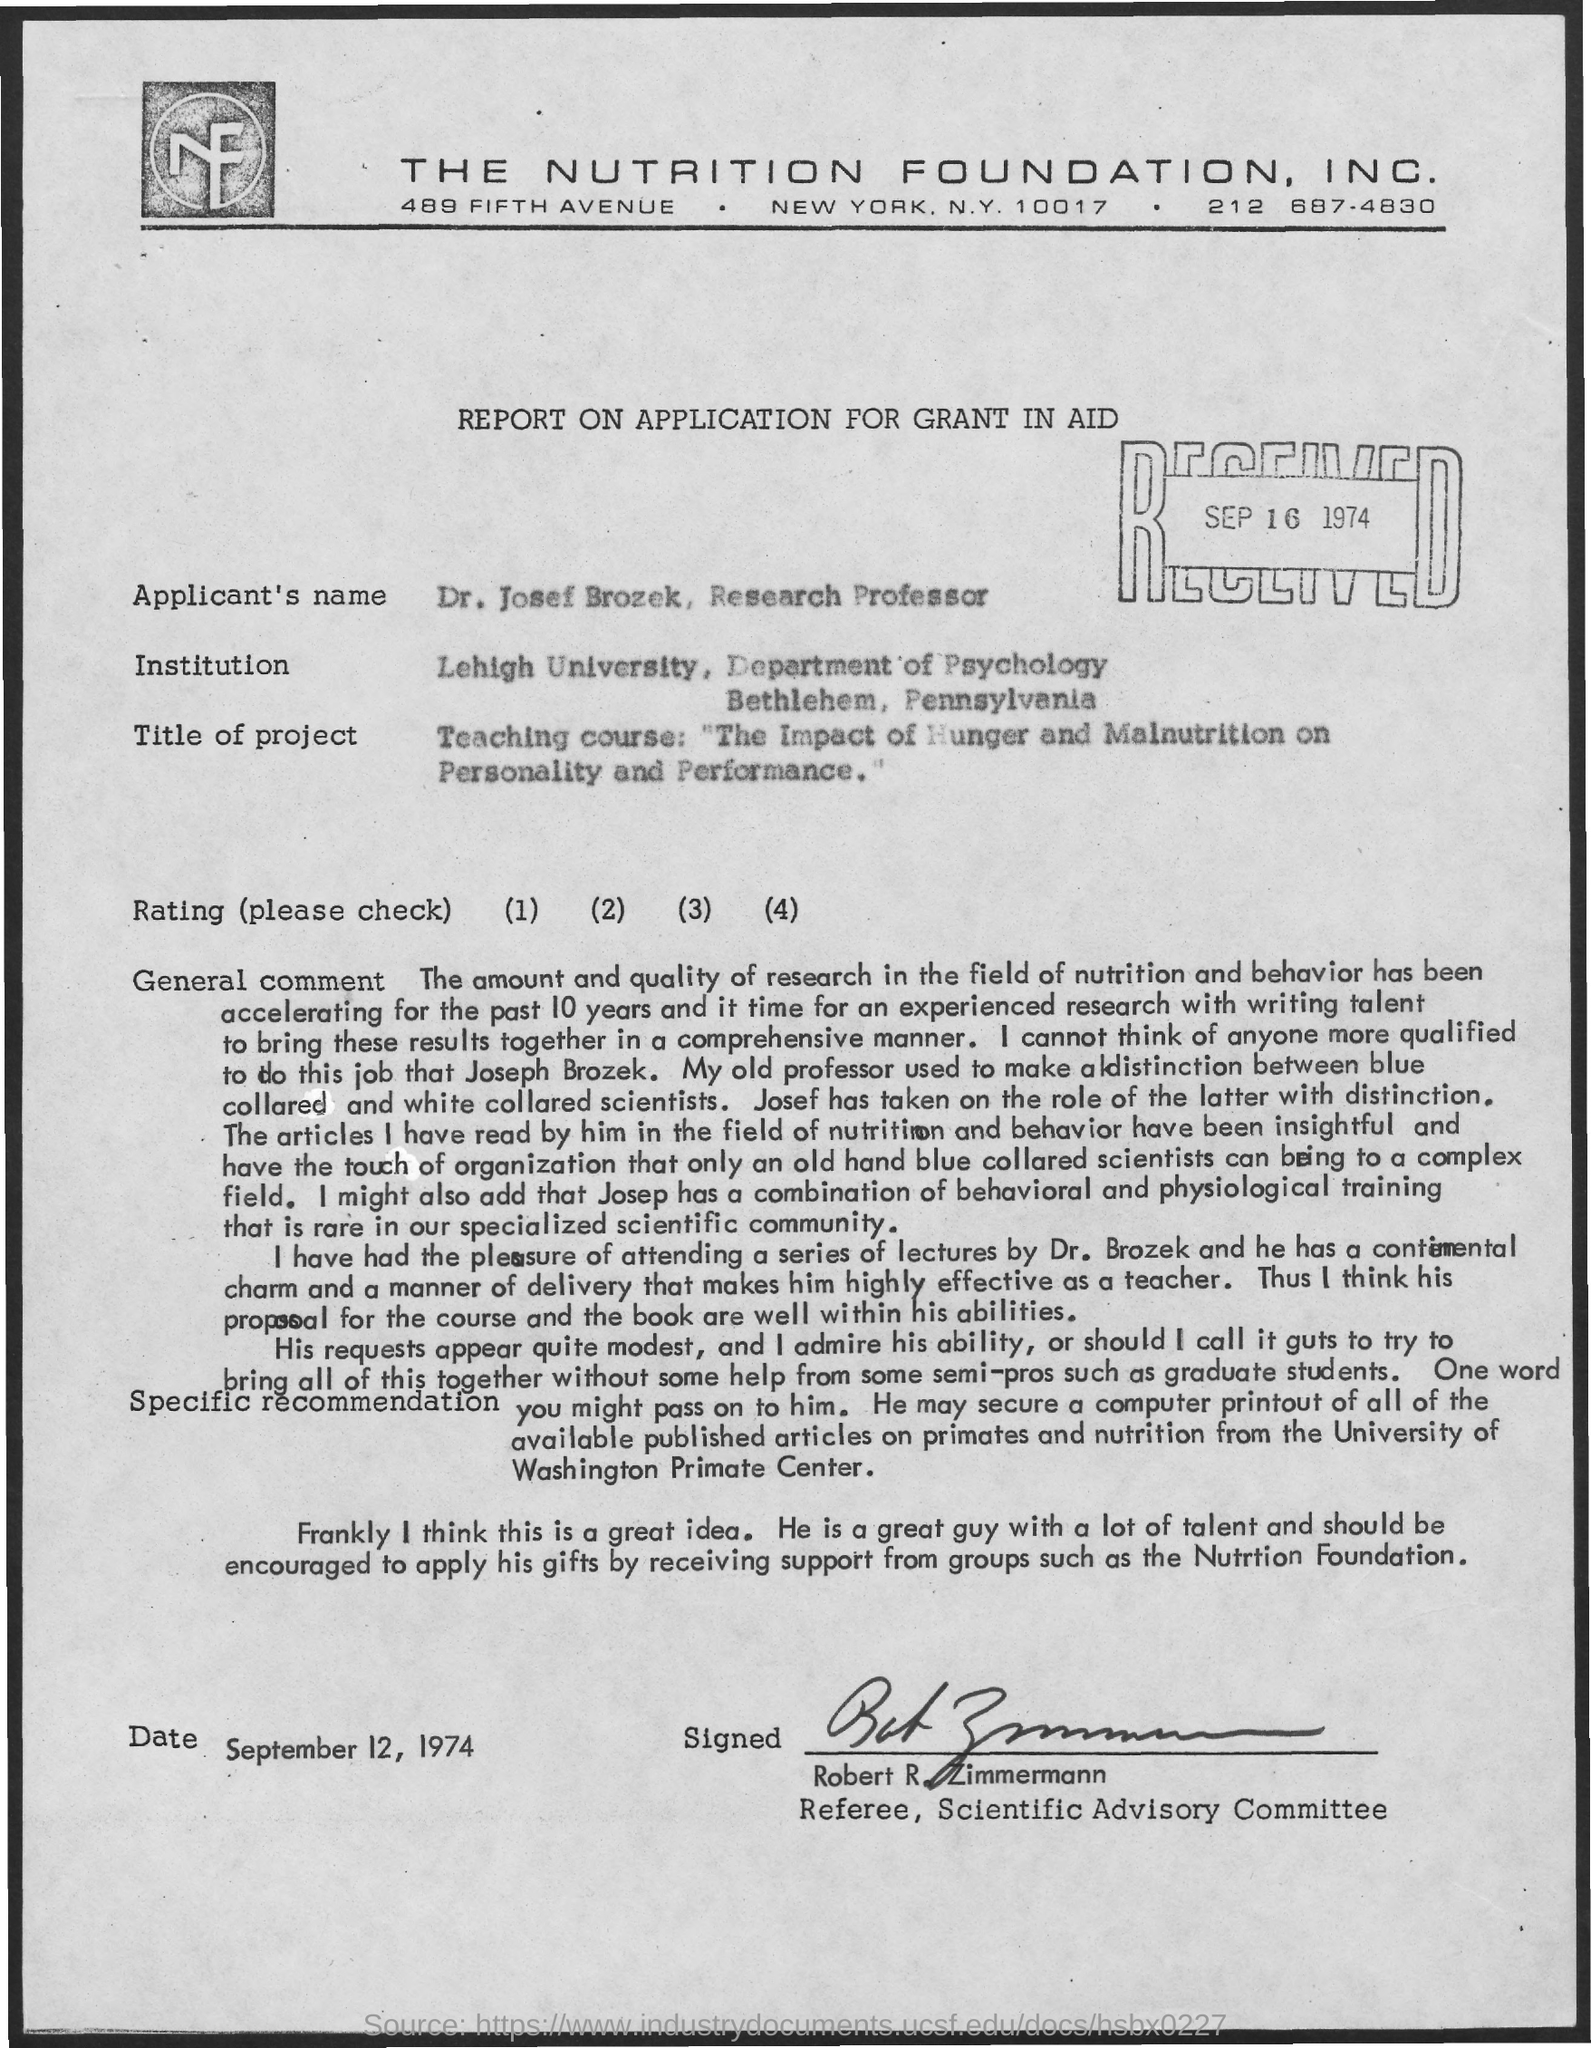Specify some key components in this picture. The contact information for The Nutrition Foundation, Inc. is as follows: its telephone number is 212 687-4830. The applicant's name is Dr. Josef Brozek, a Research Professor. The date at the bottom of the page is September 12, 1974. The report concerns the application for a grant in aid. 